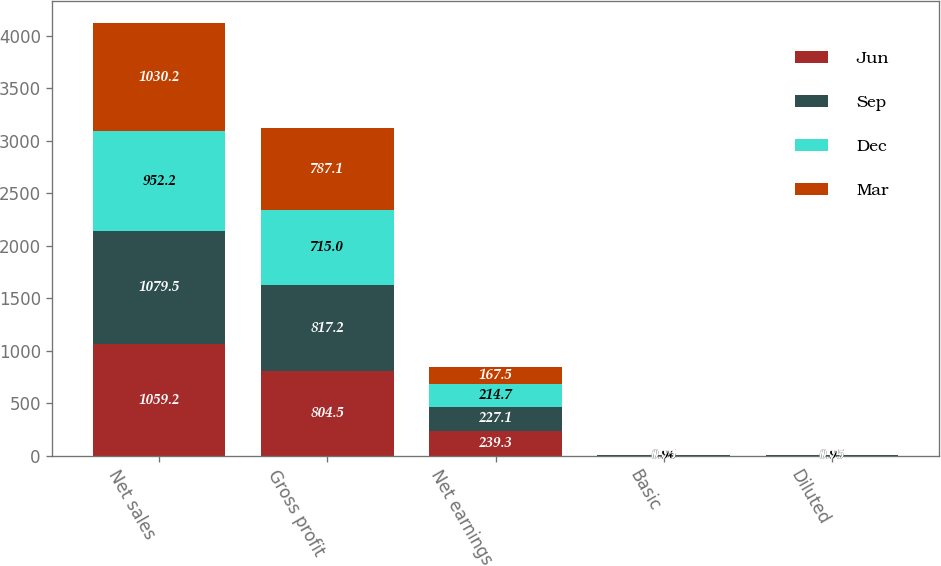<chart> <loc_0><loc_0><loc_500><loc_500><stacked_bar_chart><ecel><fcel>Net sales<fcel>Gross profit<fcel>Net earnings<fcel>Basic<fcel>Diluted<nl><fcel>Jun<fcel>1059.2<fcel>804.5<fcel>239.3<fcel>1.03<fcel>1.02<nl><fcel>Sep<fcel>1079.5<fcel>817.2<fcel>227.1<fcel>0.99<fcel>0.99<nl><fcel>Dec<fcel>952.2<fcel>715<fcel>214.7<fcel>0.96<fcel>0.95<nl><fcel>Mar<fcel>1030.2<fcel>787.1<fcel>167.5<fcel>0.75<fcel>0.75<nl></chart> 